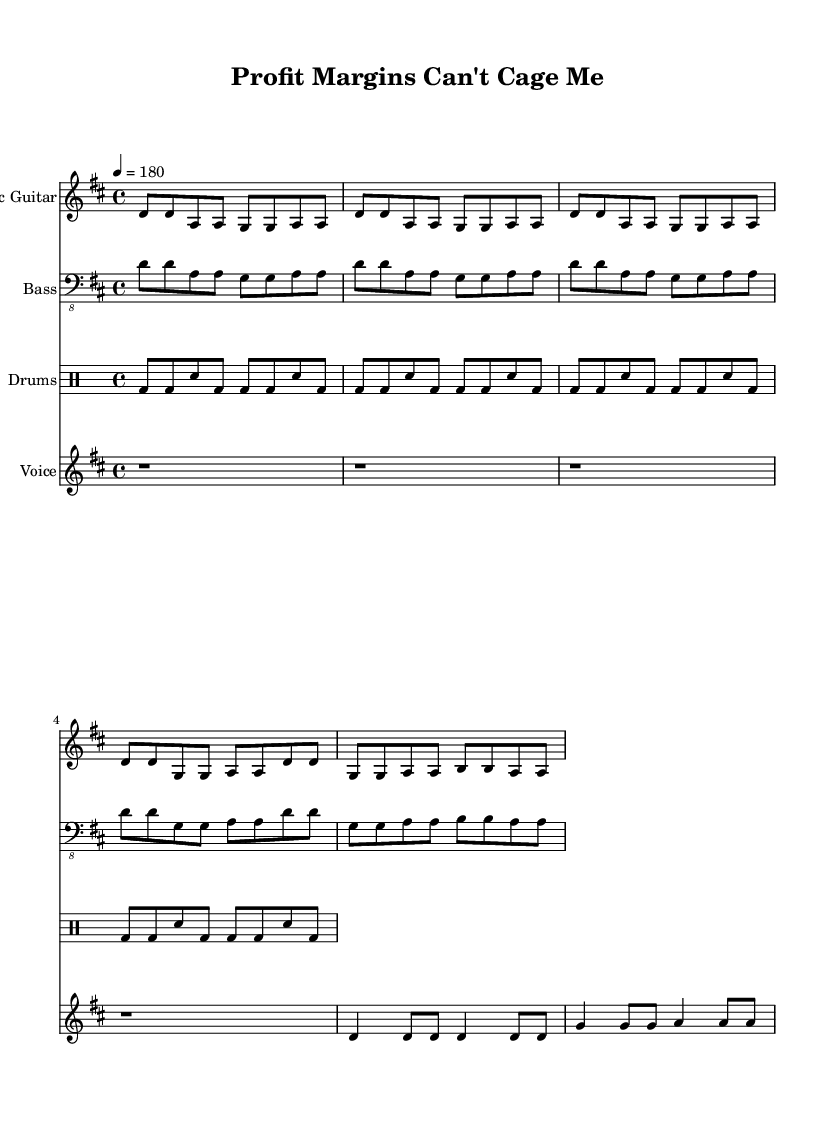What is the key signature of this music? The key signature shown is D major, which has two sharps (F# and C#). This is identifiable by looking at the signature at the beginning of the staff lines.
Answer: D major What is the time signature of this piece? The time signature, found at the beginning, is 4/4, meaning there are four beats in each measure and the quarter note gets one beat. This is indicated as a fraction at the start of the score.
Answer: 4/4 What is the tempo marking for this music? The tempo marking indicates the speed of the piece. Here, it is set at 180 beats per minute, shown as "4 = 180" which means that a quarter note is played at this fast pace.
Answer: 180 How many measures are in the verse? The verse section consists of four measures, which can be counted by tallying the sets of notes separated by bar lines in the electric guitar and bass parts within the verse lyrics.
Answer: 4 What rhythmic pattern is commonly used in punk music as seen here? The rhythmic pattern used in this piece is a basic punk beat, characterized by a steady bass drum hitting on the downbeats and snare hits typically on the backbeats. In this specific example, we see this pattern repeated throughout the drums part.
Answer: Basic punk beat What lyric theme is expressed in the chorus? The theme expressed in the chorus revolves around liberation and breaking away from corporate constraints, explicitly stating desires to be free from corporate chains and no longer following imposed rules. This thematic focus is evident in the words presented in the lyrics.
Answer: Corporate rebellion 